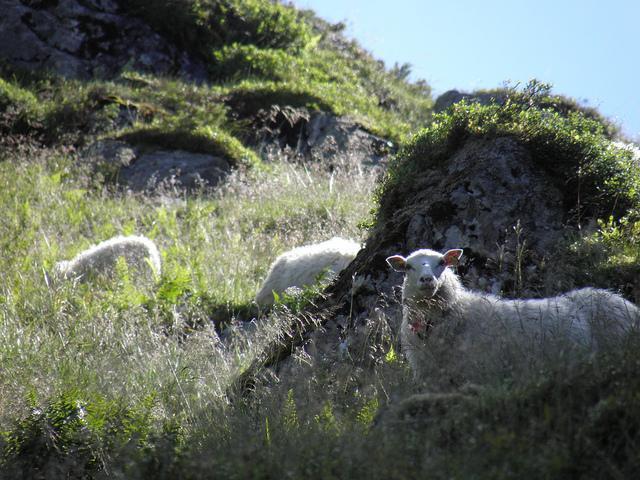What part of the animal on the right is visible?
Make your selection and explain in format: 'Answer: answer
Rationale: rationale.'
Options: Wings, tail, hooves, ears. Answer: ears.
Rationale: Of the body parts visible on the animal in question, only answer a is currently visible. 